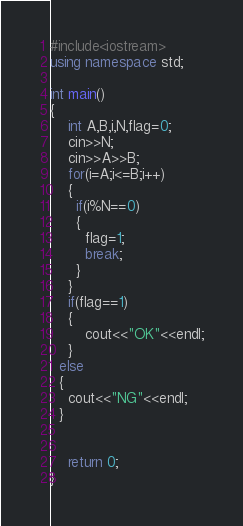<code> <loc_0><loc_0><loc_500><loc_500><_C++_>#include<iostream>
using namespace std;

int main()
{
	int A,B,i,N,flag=0;
  	cin>>N;
  	cin>>A>>B;
  	for(i=A;i<=B;i++)
    {
      if(i%N==0)
      {
      	flag=1;
        break;
      }
    }
  	if(flag==1)
    {
    	cout<<"OK"<<endl;
    }
  else
  {
  	cout<<"NG"<<endl;
  }


	return 0;
}</code> 